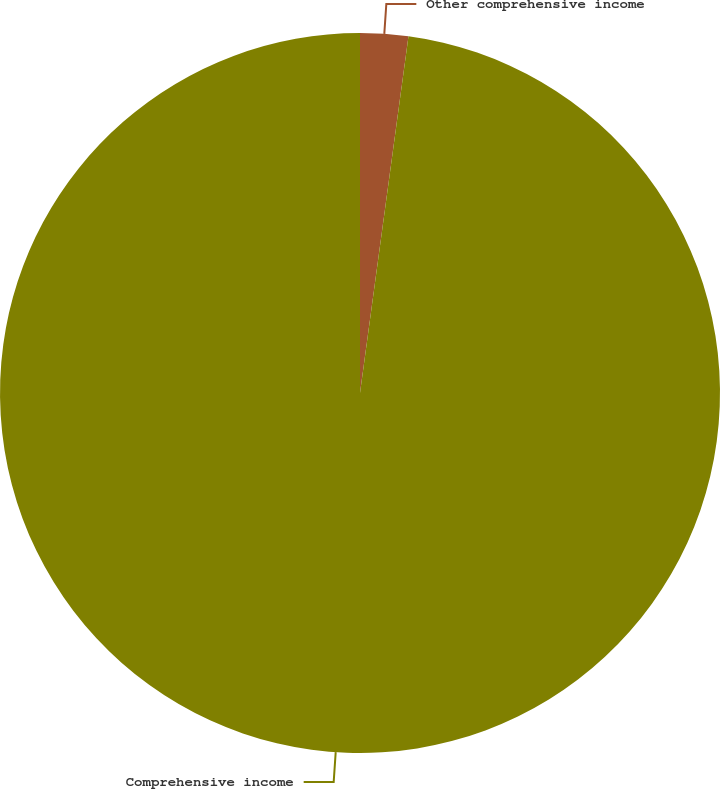Convert chart. <chart><loc_0><loc_0><loc_500><loc_500><pie_chart><fcel>Other comprehensive income<fcel>Comprehensive income<nl><fcel>2.15%<fcel>97.85%<nl></chart> 